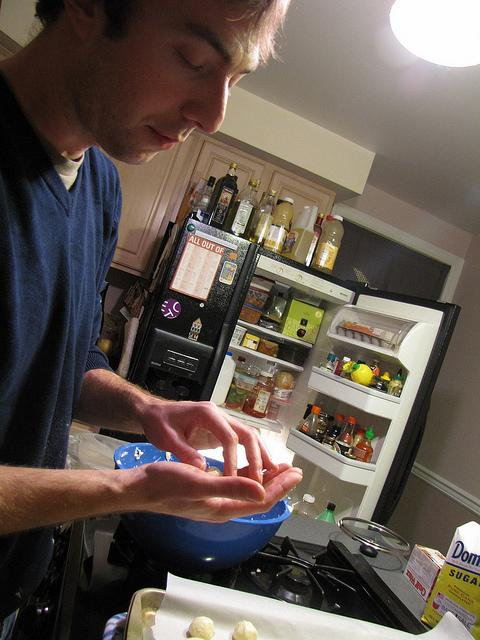What type of kitchen is shown? home 